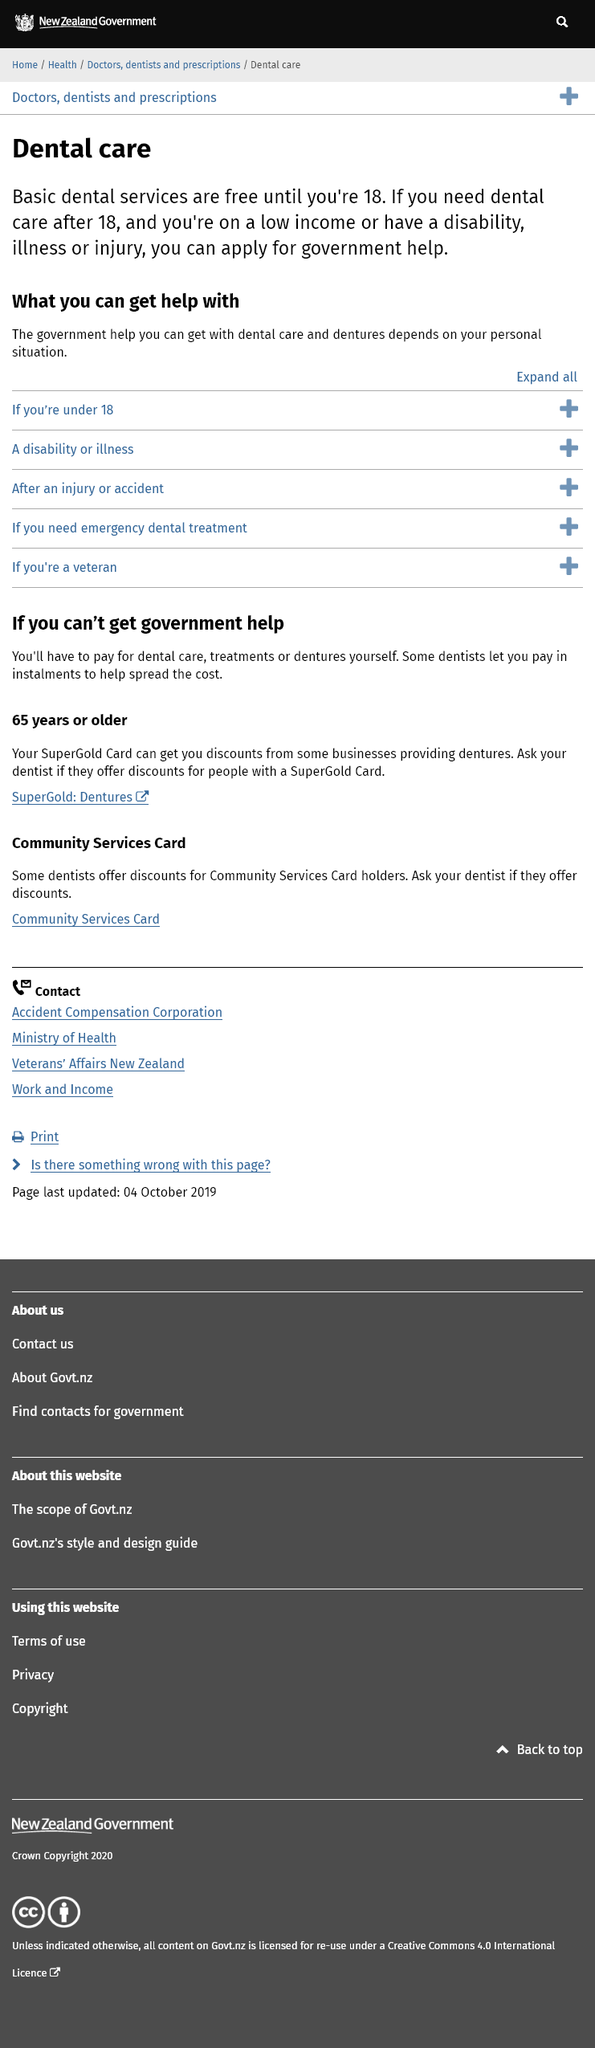Give some essential details in this illustration. Yes, the government can provide assistance to individuals with low income. The government can provide assistance with dental care for individuals based on their individual circumstances. Yes, basic dental services are free for individuals under the age of 18. 